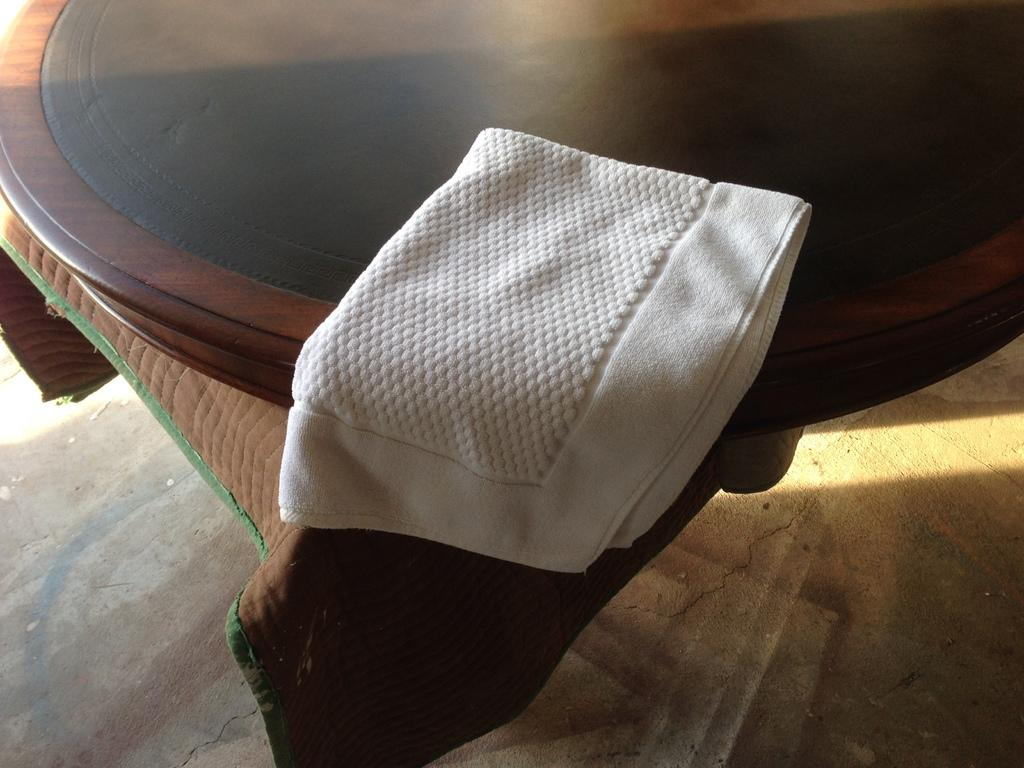What type of furniture is present in the image? There is a table in the image. What colors can be seen on the table? The table has brown and black colors. What is covering the table in the image? There is a cloth on the table. What color is the cloth on the table? The cloth has a brown color. Where is the table located in the image? The table is placed on the floor. What time of day is it in the image, and how does the team feel about the morning? The time of day is not mentioned in the image, and there is no team or reference to feelings in the image. 